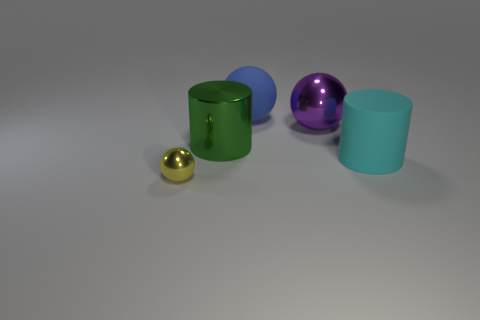Does the cylinder that is to the left of the matte ball have the same material as the big cyan cylinder in front of the blue sphere?
Make the answer very short. No. What number of large objects are made of the same material as the green cylinder?
Your answer should be very brief. 1. What material is the sphere in front of the big green cylinder?
Give a very brief answer. Metal. What is the shape of the thing in front of the big cylinder that is on the right side of the large metal object that is left of the rubber sphere?
Make the answer very short. Sphere. There is a ball in front of the big cyan thing; does it have the same color as the large matte object that is behind the purple sphere?
Your answer should be very brief. No. Is the number of cyan matte objects that are behind the large metal cylinder less than the number of yellow metallic things behind the tiny yellow metal thing?
Give a very brief answer. No. Is there anything else that is the same shape as the big green shiny thing?
Provide a short and direct response. Yes. What color is the other shiny thing that is the same shape as the small yellow object?
Keep it short and to the point. Purple. Is the shape of the yellow thing the same as the large rubber thing that is in front of the large green cylinder?
Make the answer very short. No. How many objects are tiny yellow metal spheres left of the green shiny thing or large shiny things to the right of the big metallic cylinder?
Offer a terse response. 2. 